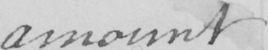Please transcribe the handwritten text in this image. amount 